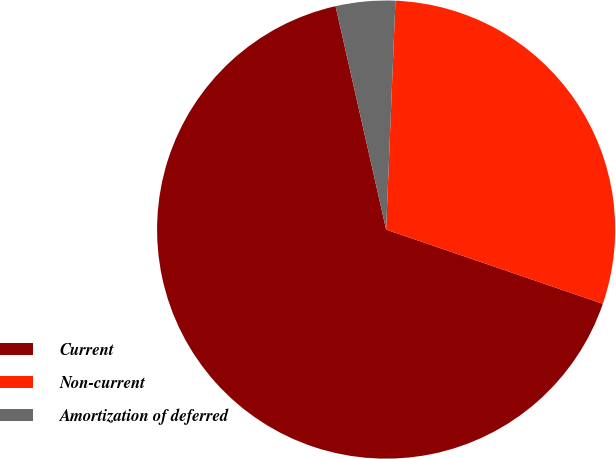Convert chart. <chart><loc_0><loc_0><loc_500><loc_500><pie_chart><fcel>Current<fcel>Non-current<fcel>Amortization of deferred<nl><fcel>66.2%<fcel>29.6%<fcel>4.19%<nl></chart> 